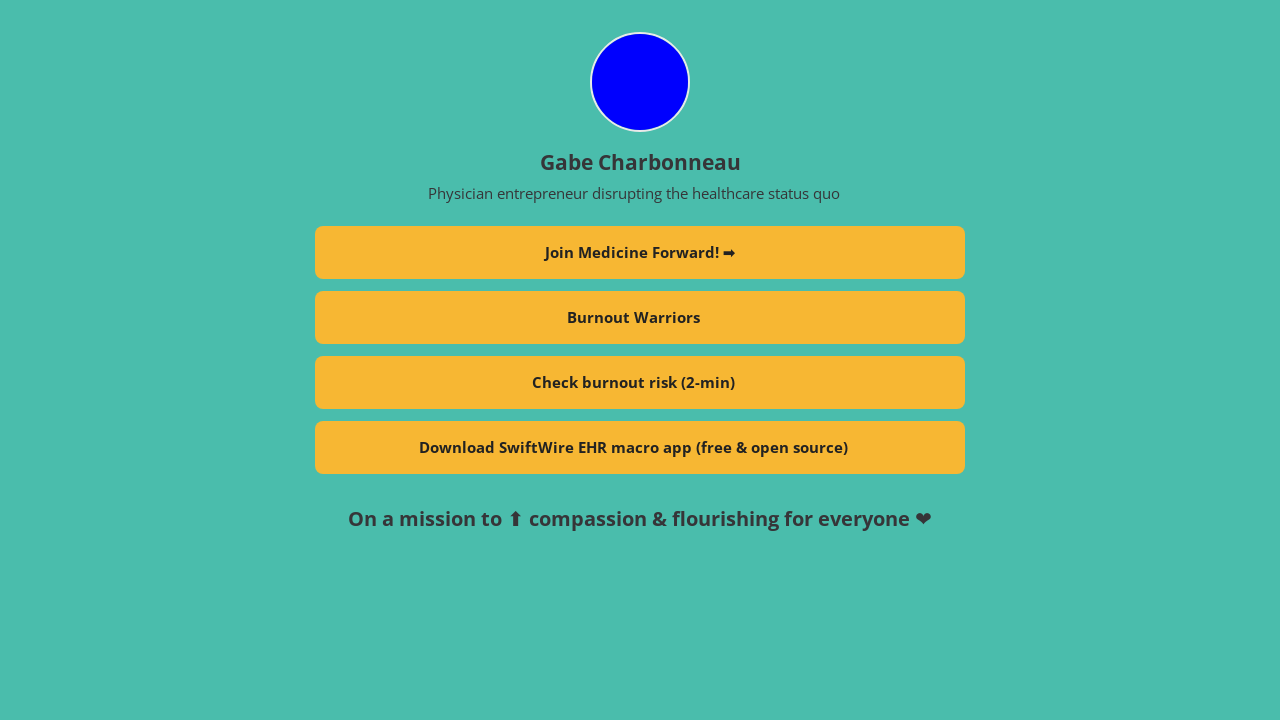How does the 'Check burnout risk (2-min)' tool work as seen on the profile? The 'Check burnout risk (2-min)' tool is likely an online assessment that evaluates signs of burnout in individuals, particularly targeting professionals in high-stress jobs like healthcare. By answering a brief series of questions, users can receive an immediate evaluation of their burnout risk level, along with resources or recommendations for managing stress and improving their mental health. 